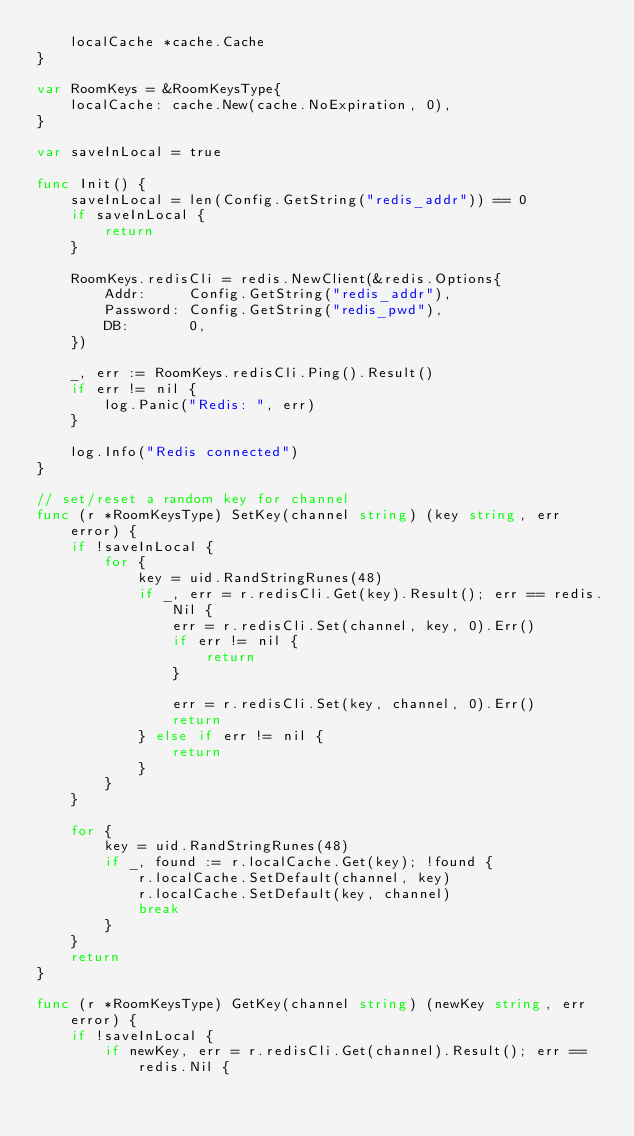<code> <loc_0><loc_0><loc_500><loc_500><_Go_>	localCache *cache.Cache
}

var RoomKeys = &RoomKeysType{
	localCache: cache.New(cache.NoExpiration, 0),
}

var saveInLocal = true

func Init() {
	saveInLocal = len(Config.GetString("redis_addr")) == 0
	if saveInLocal {
		return
	}

	RoomKeys.redisCli = redis.NewClient(&redis.Options{
		Addr:     Config.GetString("redis_addr"),
		Password: Config.GetString("redis_pwd"),
		DB:       0,
	})

	_, err := RoomKeys.redisCli.Ping().Result()
	if err != nil {
		log.Panic("Redis: ", err)
	}

	log.Info("Redis connected")
}

// set/reset a random key for channel
func (r *RoomKeysType) SetKey(channel string) (key string, err error) {
	if !saveInLocal {
		for {
			key = uid.RandStringRunes(48)
			if _, err = r.redisCli.Get(key).Result(); err == redis.Nil {
				err = r.redisCli.Set(channel, key, 0).Err()
				if err != nil {
					return
				}

				err = r.redisCli.Set(key, channel, 0).Err()
				return
			} else if err != nil {
				return
			}
		}
	}

	for {
		key = uid.RandStringRunes(48)
		if _, found := r.localCache.Get(key); !found {
			r.localCache.SetDefault(channel, key)
			r.localCache.SetDefault(key, channel)
			break
		}
	}
	return
}

func (r *RoomKeysType) GetKey(channel string) (newKey string, err error) {
	if !saveInLocal {
		if newKey, err = r.redisCli.Get(channel).Result(); err == redis.Nil {</code> 